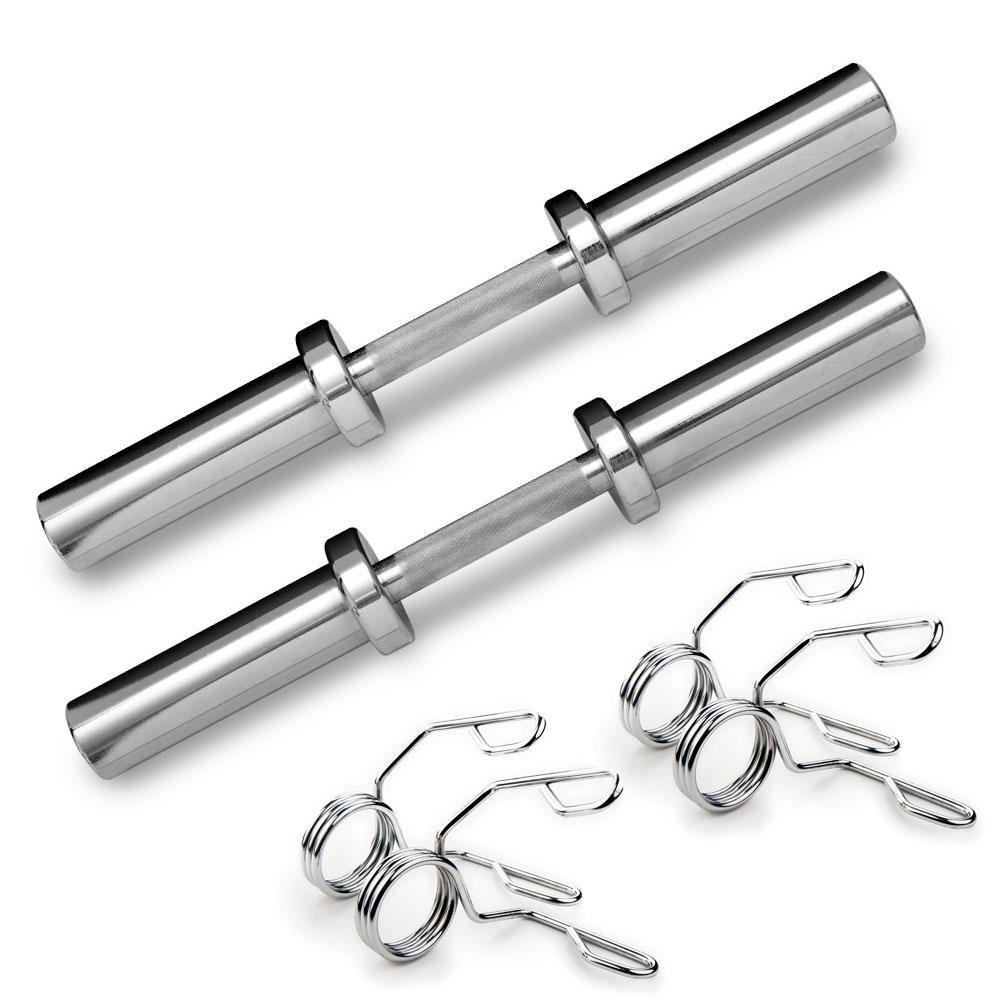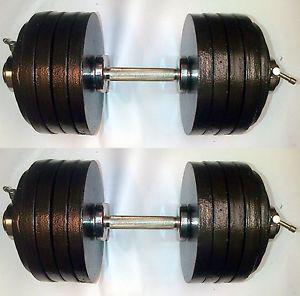The first image is the image on the left, the second image is the image on the right. Considering the images on both sides, is "One image includes at least 12 round black weights and two bars, and the other image features two chrome bars displayed parallel to each other, and a pair of wire clamp shapes next to them." valid? Answer yes or no. Yes. The first image is the image on the left, the second image is the image on the right. Considering the images on both sides, is "There are a total of four dumbbell bars with only two having weight on them." valid? Answer yes or no. Yes. 